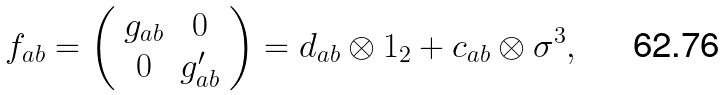Convert formula to latex. <formula><loc_0><loc_0><loc_500><loc_500>f _ { a b } = \left ( \begin{array} { c c } g _ { a b } & 0 \\ 0 & g ^ { \prime } _ { a b } \\ \end{array} \right ) = d _ { a b } \otimes { 1 } _ { 2 } + c _ { a b } \otimes \sigma ^ { 3 } ,</formula> 